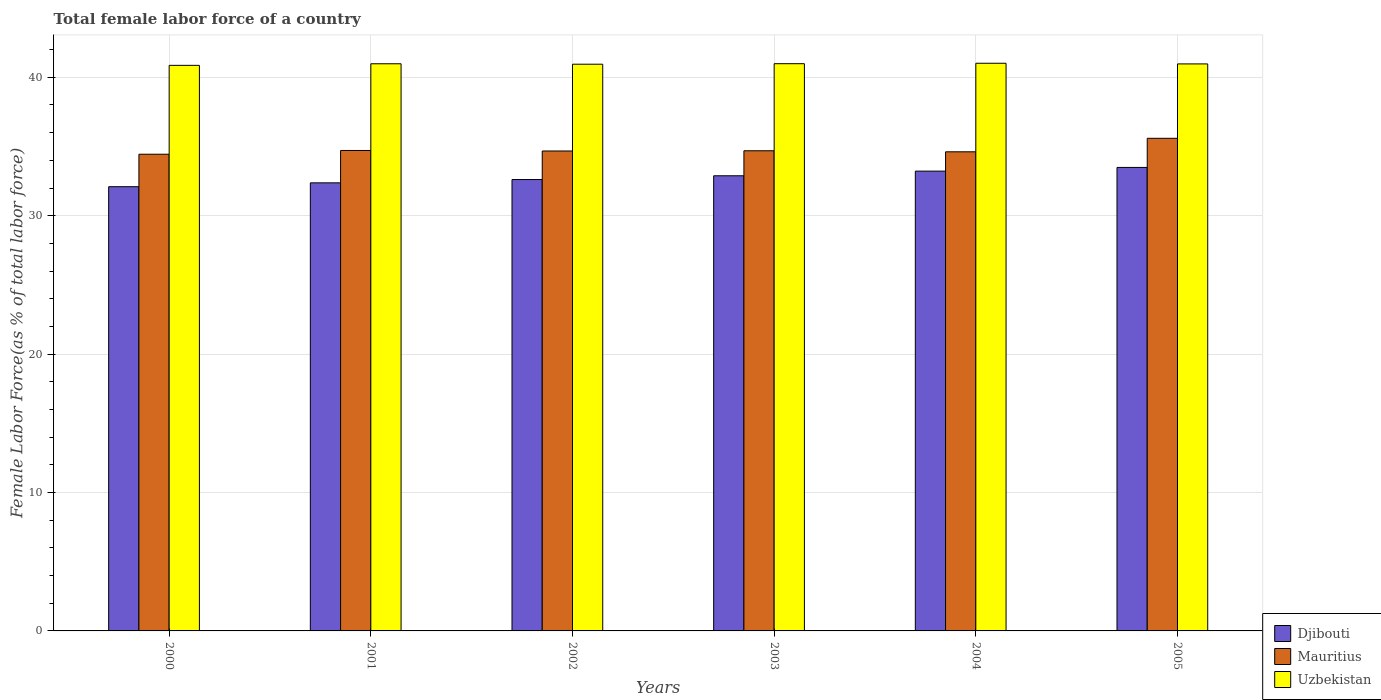What is the label of the 5th group of bars from the left?
Provide a succinct answer. 2004. In how many cases, is the number of bars for a given year not equal to the number of legend labels?
Your answer should be compact. 0. What is the percentage of female labor force in Mauritius in 2003?
Your answer should be very brief. 34.69. Across all years, what is the maximum percentage of female labor force in Mauritius?
Give a very brief answer. 35.59. Across all years, what is the minimum percentage of female labor force in Djibouti?
Ensure brevity in your answer.  32.1. In which year was the percentage of female labor force in Uzbekistan minimum?
Offer a terse response. 2000. What is the total percentage of female labor force in Uzbekistan in the graph?
Your response must be concise. 245.75. What is the difference between the percentage of female labor force in Mauritius in 2002 and that in 2004?
Offer a terse response. 0.06. What is the difference between the percentage of female labor force in Mauritius in 2001 and the percentage of female labor force in Uzbekistan in 2004?
Your answer should be very brief. -6.3. What is the average percentage of female labor force in Mauritius per year?
Give a very brief answer. 34.79. In the year 2003, what is the difference between the percentage of female labor force in Uzbekistan and percentage of female labor force in Djibouti?
Your response must be concise. 8.1. What is the ratio of the percentage of female labor force in Uzbekistan in 2004 to that in 2005?
Provide a short and direct response. 1. Is the difference between the percentage of female labor force in Uzbekistan in 2000 and 2003 greater than the difference between the percentage of female labor force in Djibouti in 2000 and 2003?
Keep it short and to the point. Yes. What is the difference between the highest and the second highest percentage of female labor force in Uzbekistan?
Give a very brief answer. 0.03. What is the difference between the highest and the lowest percentage of female labor force in Mauritius?
Your answer should be compact. 1.15. Is the sum of the percentage of female labor force in Mauritius in 2002 and 2005 greater than the maximum percentage of female labor force in Uzbekistan across all years?
Make the answer very short. Yes. What does the 1st bar from the left in 2001 represents?
Keep it short and to the point. Djibouti. What does the 3rd bar from the right in 2004 represents?
Your answer should be compact. Djibouti. Are all the bars in the graph horizontal?
Your answer should be very brief. No. What is the difference between two consecutive major ticks on the Y-axis?
Make the answer very short. 10. Does the graph contain any zero values?
Your answer should be compact. No. Where does the legend appear in the graph?
Keep it short and to the point. Bottom right. How are the legend labels stacked?
Make the answer very short. Vertical. What is the title of the graph?
Give a very brief answer. Total female labor force of a country. Does "Myanmar" appear as one of the legend labels in the graph?
Ensure brevity in your answer.  No. What is the label or title of the X-axis?
Offer a very short reply. Years. What is the label or title of the Y-axis?
Your answer should be very brief. Female Labor Force(as % of total labor force). What is the Female Labor Force(as % of total labor force) of Djibouti in 2000?
Provide a succinct answer. 32.1. What is the Female Labor Force(as % of total labor force) of Mauritius in 2000?
Provide a succinct answer. 34.44. What is the Female Labor Force(as % of total labor force) of Uzbekistan in 2000?
Provide a succinct answer. 40.86. What is the Female Labor Force(as % of total labor force) in Djibouti in 2001?
Provide a succinct answer. 32.37. What is the Female Labor Force(as % of total labor force) in Mauritius in 2001?
Offer a very short reply. 34.71. What is the Female Labor Force(as % of total labor force) in Uzbekistan in 2001?
Give a very brief answer. 40.98. What is the Female Labor Force(as % of total labor force) of Djibouti in 2002?
Provide a succinct answer. 32.61. What is the Female Labor Force(as % of total labor force) of Mauritius in 2002?
Give a very brief answer. 34.68. What is the Female Labor Force(as % of total labor force) in Uzbekistan in 2002?
Your answer should be very brief. 40.95. What is the Female Labor Force(as % of total labor force) in Djibouti in 2003?
Give a very brief answer. 32.89. What is the Female Labor Force(as % of total labor force) of Mauritius in 2003?
Give a very brief answer. 34.69. What is the Female Labor Force(as % of total labor force) in Uzbekistan in 2003?
Offer a very short reply. 40.98. What is the Female Labor Force(as % of total labor force) of Djibouti in 2004?
Your answer should be compact. 33.22. What is the Female Labor Force(as % of total labor force) in Mauritius in 2004?
Provide a short and direct response. 34.62. What is the Female Labor Force(as % of total labor force) of Uzbekistan in 2004?
Keep it short and to the point. 41.01. What is the Female Labor Force(as % of total labor force) of Djibouti in 2005?
Provide a succinct answer. 33.49. What is the Female Labor Force(as % of total labor force) of Mauritius in 2005?
Give a very brief answer. 35.59. What is the Female Labor Force(as % of total labor force) in Uzbekistan in 2005?
Offer a terse response. 40.97. Across all years, what is the maximum Female Labor Force(as % of total labor force) in Djibouti?
Provide a succinct answer. 33.49. Across all years, what is the maximum Female Labor Force(as % of total labor force) in Mauritius?
Make the answer very short. 35.59. Across all years, what is the maximum Female Labor Force(as % of total labor force) in Uzbekistan?
Keep it short and to the point. 41.01. Across all years, what is the minimum Female Labor Force(as % of total labor force) in Djibouti?
Provide a short and direct response. 32.1. Across all years, what is the minimum Female Labor Force(as % of total labor force) of Mauritius?
Give a very brief answer. 34.44. Across all years, what is the minimum Female Labor Force(as % of total labor force) of Uzbekistan?
Your answer should be very brief. 40.86. What is the total Female Labor Force(as % of total labor force) in Djibouti in the graph?
Provide a succinct answer. 196.68. What is the total Female Labor Force(as % of total labor force) in Mauritius in the graph?
Offer a very short reply. 208.73. What is the total Female Labor Force(as % of total labor force) of Uzbekistan in the graph?
Provide a short and direct response. 245.75. What is the difference between the Female Labor Force(as % of total labor force) of Djibouti in 2000 and that in 2001?
Offer a very short reply. -0.28. What is the difference between the Female Labor Force(as % of total labor force) in Mauritius in 2000 and that in 2001?
Provide a succinct answer. -0.27. What is the difference between the Female Labor Force(as % of total labor force) of Uzbekistan in 2000 and that in 2001?
Your answer should be very brief. -0.11. What is the difference between the Female Labor Force(as % of total labor force) of Djibouti in 2000 and that in 2002?
Your response must be concise. -0.52. What is the difference between the Female Labor Force(as % of total labor force) of Mauritius in 2000 and that in 2002?
Give a very brief answer. -0.23. What is the difference between the Female Labor Force(as % of total labor force) in Uzbekistan in 2000 and that in 2002?
Provide a short and direct response. -0.08. What is the difference between the Female Labor Force(as % of total labor force) in Djibouti in 2000 and that in 2003?
Offer a very short reply. -0.79. What is the difference between the Female Labor Force(as % of total labor force) of Mauritius in 2000 and that in 2003?
Ensure brevity in your answer.  -0.25. What is the difference between the Female Labor Force(as % of total labor force) of Uzbekistan in 2000 and that in 2003?
Ensure brevity in your answer.  -0.12. What is the difference between the Female Labor Force(as % of total labor force) of Djibouti in 2000 and that in 2004?
Offer a terse response. -1.13. What is the difference between the Female Labor Force(as % of total labor force) in Mauritius in 2000 and that in 2004?
Make the answer very short. -0.17. What is the difference between the Female Labor Force(as % of total labor force) of Uzbekistan in 2000 and that in 2004?
Ensure brevity in your answer.  -0.15. What is the difference between the Female Labor Force(as % of total labor force) of Djibouti in 2000 and that in 2005?
Keep it short and to the point. -1.39. What is the difference between the Female Labor Force(as % of total labor force) of Mauritius in 2000 and that in 2005?
Ensure brevity in your answer.  -1.15. What is the difference between the Female Labor Force(as % of total labor force) of Uzbekistan in 2000 and that in 2005?
Provide a succinct answer. -0.1. What is the difference between the Female Labor Force(as % of total labor force) of Djibouti in 2001 and that in 2002?
Your answer should be very brief. -0.24. What is the difference between the Female Labor Force(as % of total labor force) in Mauritius in 2001 and that in 2002?
Keep it short and to the point. 0.04. What is the difference between the Female Labor Force(as % of total labor force) of Uzbekistan in 2001 and that in 2002?
Provide a short and direct response. 0.03. What is the difference between the Female Labor Force(as % of total labor force) of Djibouti in 2001 and that in 2003?
Your response must be concise. -0.51. What is the difference between the Female Labor Force(as % of total labor force) of Mauritius in 2001 and that in 2003?
Your answer should be very brief. 0.02. What is the difference between the Female Labor Force(as % of total labor force) in Uzbekistan in 2001 and that in 2003?
Make the answer very short. -0.01. What is the difference between the Female Labor Force(as % of total labor force) in Djibouti in 2001 and that in 2004?
Offer a terse response. -0.85. What is the difference between the Female Labor Force(as % of total labor force) of Mauritius in 2001 and that in 2004?
Offer a very short reply. 0.1. What is the difference between the Female Labor Force(as % of total labor force) of Uzbekistan in 2001 and that in 2004?
Ensure brevity in your answer.  -0.04. What is the difference between the Female Labor Force(as % of total labor force) in Djibouti in 2001 and that in 2005?
Offer a terse response. -1.11. What is the difference between the Female Labor Force(as % of total labor force) in Mauritius in 2001 and that in 2005?
Offer a terse response. -0.88. What is the difference between the Female Labor Force(as % of total labor force) in Uzbekistan in 2001 and that in 2005?
Ensure brevity in your answer.  0.01. What is the difference between the Female Labor Force(as % of total labor force) of Djibouti in 2002 and that in 2003?
Your answer should be compact. -0.27. What is the difference between the Female Labor Force(as % of total labor force) of Mauritius in 2002 and that in 2003?
Offer a terse response. -0.02. What is the difference between the Female Labor Force(as % of total labor force) in Uzbekistan in 2002 and that in 2003?
Your answer should be compact. -0.04. What is the difference between the Female Labor Force(as % of total labor force) in Djibouti in 2002 and that in 2004?
Ensure brevity in your answer.  -0.61. What is the difference between the Female Labor Force(as % of total labor force) of Mauritius in 2002 and that in 2004?
Provide a succinct answer. 0.06. What is the difference between the Female Labor Force(as % of total labor force) in Uzbekistan in 2002 and that in 2004?
Give a very brief answer. -0.07. What is the difference between the Female Labor Force(as % of total labor force) of Djibouti in 2002 and that in 2005?
Keep it short and to the point. -0.87. What is the difference between the Female Labor Force(as % of total labor force) of Mauritius in 2002 and that in 2005?
Keep it short and to the point. -0.92. What is the difference between the Female Labor Force(as % of total labor force) of Uzbekistan in 2002 and that in 2005?
Keep it short and to the point. -0.02. What is the difference between the Female Labor Force(as % of total labor force) in Djibouti in 2003 and that in 2004?
Provide a succinct answer. -0.34. What is the difference between the Female Labor Force(as % of total labor force) of Mauritius in 2003 and that in 2004?
Ensure brevity in your answer.  0.08. What is the difference between the Female Labor Force(as % of total labor force) in Uzbekistan in 2003 and that in 2004?
Give a very brief answer. -0.03. What is the difference between the Female Labor Force(as % of total labor force) of Djibouti in 2003 and that in 2005?
Your answer should be compact. -0.6. What is the difference between the Female Labor Force(as % of total labor force) in Mauritius in 2003 and that in 2005?
Keep it short and to the point. -0.9. What is the difference between the Female Labor Force(as % of total labor force) in Uzbekistan in 2003 and that in 2005?
Offer a terse response. 0.02. What is the difference between the Female Labor Force(as % of total labor force) in Djibouti in 2004 and that in 2005?
Your response must be concise. -0.27. What is the difference between the Female Labor Force(as % of total labor force) in Mauritius in 2004 and that in 2005?
Make the answer very short. -0.98. What is the difference between the Female Labor Force(as % of total labor force) in Uzbekistan in 2004 and that in 2005?
Your response must be concise. 0.05. What is the difference between the Female Labor Force(as % of total labor force) in Djibouti in 2000 and the Female Labor Force(as % of total labor force) in Mauritius in 2001?
Your answer should be compact. -2.62. What is the difference between the Female Labor Force(as % of total labor force) in Djibouti in 2000 and the Female Labor Force(as % of total labor force) in Uzbekistan in 2001?
Offer a very short reply. -8.88. What is the difference between the Female Labor Force(as % of total labor force) in Mauritius in 2000 and the Female Labor Force(as % of total labor force) in Uzbekistan in 2001?
Make the answer very short. -6.54. What is the difference between the Female Labor Force(as % of total labor force) of Djibouti in 2000 and the Female Labor Force(as % of total labor force) of Mauritius in 2002?
Give a very brief answer. -2.58. What is the difference between the Female Labor Force(as % of total labor force) in Djibouti in 2000 and the Female Labor Force(as % of total labor force) in Uzbekistan in 2002?
Offer a very short reply. -8.85. What is the difference between the Female Labor Force(as % of total labor force) in Mauritius in 2000 and the Female Labor Force(as % of total labor force) in Uzbekistan in 2002?
Offer a terse response. -6.5. What is the difference between the Female Labor Force(as % of total labor force) in Djibouti in 2000 and the Female Labor Force(as % of total labor force) in Mauritius in 2003?
Keep it short and to the point. -2.6. What is the difference between the Female Labor Force(as % of total labor force) in Djibouti in 2000 and the Female Labor Force(as % of total labor force) in Uzbekistan in 2003?
Ensure brevity in your answer.  -8.89. What is the difference between the Female Labor Force(as % of total labor force) in Mauritius in 2000 and the Female Labor Force(as % of total labor force) in Uzbekistan in 2003?
Give a very brief answer. -6.54. What is the difference between the Female Labor Force(as % of total labor force) of Djibouti in 2000 and the Female Labor Force(as % of total labor force) of Mauritius in 2004?
Ensure brevity in your answer.  -2.52. What is the difference between the Female Labor Force(as % of total labor force) in Djibouti in 2000 and the Female Labor Force(as % of total labor force) in Uzbekistan in 2004?
Make the answer very short. -8.92. What is the difference between the Female Labor Force(as % of total labor force) of Mauritius in 2000 and the Female Labor Force(as % of total labor force) of Uzbekistan in 2004?
Provide a succinct answer. -6.57. What is the difference between the Female Labor Force(as % of total labor force) in Djibouti in 2000 and the Female Labor Force(as % of total labor force) in Mauritius in 2005?
Provide a succinct answer. -3.5. What is the difference between the Female Labor Force(as % of total labor force) of Djibouti in 2000 and the Female Labor Force(as % of total labor force) of Uzbekistan in 2005?
Make the answer very short. -8.87. What is the difference between the Female Labor Force(as % of total labor force) of Mauritius in 2000 and the Female Labor Force(as % of total labor force) of Uzbekistan in 2005?
Provide a succinct answer. -6.52. What is the difference between the Female Labor Force(as % of total labor force) of Djibouti in 2001 and the Female Labor Force(as % of total labor force) of Mauritius in 2002?
Keep it short and to the point. -2.3. What is the difference between the Female Labor Force(as % of total labor force) in Djibouti in 2001 and the Female Labor Force(as % of total labor force) in Uzbekistan in 2002?
Your response must be concise. -8.57. What is the difference between the Female Labor Force(as % of total labor force) of Mauritius in 2001 and the Female Labor Force(as % of total labor force) of Uzbekistan in 2002?
Provide a succinct answer. -6.23. What is the difference between the Female Labor Force(as % of total labor force) in Djibouti in 2001 and the Female Labor Force(as % of total labor force) in Mauritius in 2003?
Provide a short and direct response. -2.32. What is the difference between the Female Labor Force(as % of total labor force) in Djibouti in 2001 and the Female Labor Force(as % of total labor force) in Uzbekistan in 2003?
Provide a succinct answer. -8.61. What is the difference between the Female Labor Force(as % of total labor force) of Mauritius in 2001 and the Female Labor Force(as % of total labor force) of Uzbekistan in 2003?
Your response must be concise. -6.27. What is the difference between the Female Labor Force(as % of total labor force) of Djibouti in 2001 and the Female Labor Force(as % of total labor force) of Mauritius in 2004?
Ensure brevity in your answer.  -2.24. What is the difference between the Female Labor Force(as % of total labor force) of Djibouti in 2001 and the Female Labor Force(as % of total labor force) of Uzbekistan in 2004?
Offer a very short reply. -8.64. What is the difference between the Female Labor Force(as % of total labor force) of Mauritius in 2001 and the Female Labor Force(as % of total labor force) of Uzbekistan in 2004?
Make the answer very short. -6.3. What is the difference between the Female Labor Force(as % of total labor force) of Djibouti in 2001 and the Female Labor Force(as % of total labor force) of Mauritius in 2005?
Keep it short and to the point. -3.22. What is the difference between the Female Labor Force(as % of total labor force) in Djibouti in 2001 and the Female Labor Force(as % of total labor force) in Uzbekistan in 2005?
Offer a very short reply. -8.59. What is the difference between the Female Labor Force(as % of total labor force) of Mauritius in 2001 and the Female Labor Force(as % of total labor force) of Uzbekistan in 2005?
Make the answer very short. -6.25. What is the difference between the Female Labor Force(as % of total labor force) of Djibouti in 2002 and the Female Labor Force(as % of total labor force) of Mauritius in 2003?
Your answer should be compact. -2.08. What is the difference between the Female Labor Force(as % of total labor force) of Djibouti in 2002 and the Female Labor Force(as % of total labor force) of Uzbekistan in 2003?
Offer a terse response. -8.37. What is the difference between the Female Labor Force(as % of total labor force) of Mauritius in 2002 and the Female Labor Force(as % of total labor force) of Uzbekistan in 2003?
Provide a succinct answer. -6.31. What is the difference between the Female Labor Force(as % of total labor force) in Djibouti in 2002 and the Female Labor Force(as % of total labor force) in Mauritius in 2004?
Keep it short and to the point. -2. What is the difference between the Female Labor Force(as % of total labor force) in Djibouti in 2002 and the Female Labor Force(as % of total labor force) in Uzbekistan in 2004?
Provide a short and direct response. -8.4. What is the difference between the Female Labor Force(as % of total labor force) in Mauritius in 2002 and the Female Labor Force(as % of total labor force) in Uzbekistan in 2004?
Give a very brief answer. -6.34. What is the difference between the Female Labor Force(as % of total labor force) in Djibouti in 2002 and the Female Labor Force(as % of total labor force) in Mauritius in 2005?
Your answer should be compact. -2.98. What is the difference between the Female Labor Force(as % of total labor force) of Djibouti in 2002 and the Female Labor Force(as % of total labor force) of Uzbekistan in 2005?
Make the answer very short. -8.35. What is the difference between the Female Labor Force(as % of total labor force) in Mauritius in 2002 and the Female Labor Force(as % of total labor force) in Uzbekistan in 2005?
Provide a short and direct response. -6.29. What is the difference between the Female Labor Force(as % of total labor force) of Djibouti in 2003 and the Female Labor Force(as % of total labor force) of Mauritius in 2004?
Offer a terse response. -1.73. What is the difference between the Female Labor Force(as % of total labor force) in Djibouti in 2003 and the Female Labor Force(as % of total labor force) in Uzbekistan in 2004?
Provide a short and direct response. -8.13. What is the difference between the Female Labor Force(as % of total labor force) in Mauritius in 2003 and the Female Labor Force(as % of total labor force) in Uzbekistan in 2004?
Offer a very short reply. -6.32. What is the difference between the Female Labor Force(as % of total labor force) in Djibouti in 2003 and the Female Labor Force(as % of total labor force) in Mauritius in 2005?
Offer a very short reply. -2.71. What is the difference between the Female Labor Force(as % of total labor force) in Djibouti in 2003 and the Female Labor Force(as % of total labor force) in Uzbekistan in 2005?
Your answer should be very brief. -8.08. What is the difference between the Female Labor Force(as % of total labor force) in Mauritius in 2003 and the Female Labor Force(as % of total labor force) in Uzbekistan in 2005?
Provide a succinct answer. -6.27. What is the difference between the Female Labor Force(as % of total labor force) in Djibouti in 2004 and the Female Labor Force(as % of total labor force) in Mauritius in 2005?
Provide a short and direct response. -2.37. What is the difference between the Female Labor Force(as % of total labor force) of Djibouti in 2004 and the Female Labor Force(as % of total labor force) of Uzbekistan in 2005?
Keep it short and to the point. -7.75. What is the difference between the Female Labor Force(as % of total labor force) in Mauritius in 2004 and the Female Labor Force(as % of total labor force) in Uzbekistan in 2005?
Give a very brief answer. -6.35. What is the average Female Labor Force(as % of total labor force) of Djibouti per year?
Provide a succinct answer. 32.78. What is the average Female Labor Force(as % of total labor force) of Mauritius per year?
Give a very brief answer. 34.79. What is the average Female Labor Force(as % of total labor force) of Uzbekistan per year?
Your response must be concise. 40.96. In the year 2000, what is the difference between the Female Labor Force(as % of total labor force) of Djibouti and Female Labor Force(as % of total labor force) of Mauritius?
Your answer should be compact. -2.35. In the year 2000, what is the difference between the Female Labor Force(as % of total labor force) of Djibouti and Female Labor Force(as % of total labor force) of Uzbekistan?
Offer a very short reply. -8.77. In the year 2000, what is the difference between the Female Labor Force(as % of total labor force) in Mauritius and Female Labor Force(as % of total labor force) in Uzbekistan?
Give a very brief answer. -6.42. In the year 2001, what is the difference between the Female Labor Force(as % of total labor force) of Djibouti and Female Labor Force(as % of total labor force) of Mauritius?
Your answer should be compact. -2.34. In the year 2001, what is the difference between the Female Labor Force(as % of total labor force) of Djibouti and Female Labor Force(as % of total labor force) of Uzbekistan?
Keep it short and to the point. -8.6. In the year 2001, what is the difference between the Female Labor Force(as % of total labor force) in Mauritius and Female Labor Force(as % of total labor force) in Uzbekistan?
Offer a very short reply. -6.26. In the year 2002, what is the difference between the Female Labor Force(as % of total labor force) of Djibouti and Female Labor Force(as % of total labor force) of Mauritius?
Keep it short and to the point. -2.06. In the year 2002, what is the difference between the Female Labor Force(as % of total labor force) in Djibouti and Female Labor Force(as % of total labor force) in Uzbekistan?
Keep it short and to the point. -8.33. In the year 2002, what is the difference between the Female Labor Force(as % of total labor force) in Mauritius and Female Labor Force(as % of total labor force) in Uzbekistan?
Your answer should be very brief. -6.27. In the year 2003, what is the difference between the Female Labor Force(as % of total labor force) in Djibouti and Female Labor Force(as % of total labor force) in Mauritius?
Offer a terse response. -1.81. In the year 2003, what is the difference between the Female Labor Force(as % of total labor force) of Djibouti and Female Labor Force(as % of total labor force) of Uzbekistan?
Ensure brevity in your answer.  -8.1. In the year 2003, what is the difference between the Female Labor Force(as % of total labor force) of Mauritius and Female Labor Force(as % of total labor force) of Uzbekistan?
Give a very brief answer. -6.29. In the year 2004, what is the difference between the Female Labor Force(as % of total labor force) in Djibouti and Female Labor Force(as % of total labor force) in Mauritius?
Your answer should be compact. -1.4. In the year 2004, what is the difference between the Female Labor Force(as % of total labor force) in Djibouti and Female Labor Force(as % of total labor force) in Uzbekistan?
Your answer should be very brief. -7.79. In the year 2004, what is the difference between the Female Labor Force(as % of total labor force) in Mauritius and Female Labor Force(as % of total labor force) in Uzbekistan?
Keep it short and to the point. -6.4. In the year 2005, what is the difference between the Female Labor Force(as % of total labor force) in Djibouti and Female Labor Force(as % of total labor force) in Mauritius?
Your answer should be compact. -2.1. In the year 2005, what is the difference between the Female Labor Force(as % of total labor force) of Djibouti and Female Labor Force(as % of total labor force) of Uzbekistan?
Make the answer very short. -7.48. In the year 2005, what is the difference between the Female Labor Force(as % of total labor force) of Mauritius and Female Labor Force(as % of total labor force) of Uzbekistan?
Give a very brief answer. -5.37. What is the ratio of the Female Labor Force(as % of total labor force) in Djibouti in 2000 to that in 2001?
Your answer should be very brief. 0.99. What is the ratio of the Female Labor Force(as % of total labor force) in Uzbekistan in 2000 to that in 2001?
Ensure brevity in your answer.  1. What is the ratio of the Female Labor Force(as % of total labor force) in Djibouti in 2000 to that in 2002?
Your response must be concise. 0.98. What is the ratio of the Female Labor Force(as % of total labor force) in Mauritius in 2000 to that in 2002?
Offer a very short reply. 0.99. What is the ratio of the Female Labor Force(as % of total labor force) in Uzbekistan in 2000 to that in 2003?
Provide a short and direct response. 1. What is the ratio of the Female Labor Force(as % of total labor force) in Djibouti in 2000 to that in 2004?
Your response must be concise. 0.97. What is the ratio of the Female Labor Force(as % of total labor force) of Mauritius in 2000 to that in 2004?
Provide a short and direct response. 0.99. What is the ratio of the Female Labor Force(as % of total labor force) in Djibouti in 2000 to that in 2005?
Your answer should be compact. 0.96. What is the ratio of the Female Labor Force(as % of total labor force) of Mauritius in 2000 to that in 2005?
Offer a very short reply. 0.97. What is the ratio of the Female Labor Force(as % of total labor force) in Mauritius in 2001 to that in 2002?
Keep it short and to the point. 1. What is the ratio of the Female Labor Force(as % of total labor force) of Uzbekistan in 2001 to that in 2002?
Keep it short and to the point. 1. What is the ratio of the Female Labor Force(as % of total labor force) in Djibouti in 2001 to that in 2003?
Provide a succinct answer. 0.98. What is the ratio of the Female Labor Force(as % of total labor force) of Mauritius in 2001 to that in 2003?
Offer a very short reply. 1. What is the ratio of the Female Labor Force(as % of total labor force) of Djibouti in 2001 to that in 2004?
Keep it short and to the point. 0.97. What is the ratio of the Female Labor Force(as % of total labor force) in Uzbekistan in 2001 to that in 2004?
Offer a very short reply. 1. What is the ratio of the Female Labor Force(as % of total labor force) in Djibouti in 2001 to that in 2005?
Your answer should be compact. 0.97. What is the ratio of the Female Labor Force(as % of total labor force) of Mauritius in 2001 to that in 2005?
Give a very brief answer. 0.98. What is the ratio of the Female Labor Force(as % of total labor force) in Uzbekistan in 2001 to that in 2005?
Give a very brief answer. 1. What is the ratio of the Female Labor Force(as % of total labor force) in Uzbekistan in 2002 to that in 2003?
Your answer should be compact. 1. What is the ratio of the Female Labor Force(as % of total labor force) of Djibouti in 2002 to that in 2004?
Give a very brief answer. 0.98. What is the ratio of the Female Labor Force(as % of total labor force) of Mauritius in 2002 to that in 2004?
Make the answer very short. 1. What is the ratio of the Female Labor Force(as % of total labor force) of Uzbekistan in 2002 to that in 2004?
Make the answer very short. 1. What is the ratio of the Female Labor Force(as % of total labor force) of Djibouti in 2002 to that in 2005?
Give a very brief answer. 0.97. What is the ratio of the Female Labor Force(as % of total labor force) of Mauritius in 2002 to that in 2005?
Provide a short and direct response. 0.97. What is the ratio of the Female Labor Force(as % of total labor force) of Uzbekistan in 2002 to that in 2005?
Offer a very short reply. 1. What is the ratio of the Female Labor Force(as % of total labor force) in Mauritius in 2003 to that in 2004?
Provide a short and direct response. 1. What is the ratio of the Female Labor Force(as % of total labor force) of Djibouti in 2003 to that in 2005?
Provide a succinct answer. 0.98. What is the ratio of the Female Labor Force(as % of total labor force) of Mauritius in 2003 to that in 2005?
Give a very brief answer. 0.97. What is the ratio of the Female Labor Force(as % of total labor force) of Uzbekistan in 2003 to that in 2005?
Make the answer very short. 1. What is the ratio of the Female Labor Force(as % of total labor force) in Djibouti in 2004 to that in 2005?
Offer a very short reply. 0.99. What is the ratio of the Female Labor Force(as % of total labor force) in Mauritius in 2004 to that in 2005?
Offer a very short reply. 0.97. What is the ratio of the Female Labor Force(as % of total labor force) in Uzbekistan in 2004 to that in 2005?
Your answer should be compact. 1. What is the difference between the highest and the second highest Female Labor Force(as % of total labor force) in Djibouti?
Your answer should be compact. 0.27. What is the difference between the highest and the second highest Female Labor Force(as % of total labor force) of Mauritius?
Make the answer very short. 0.88. What is the difference between the highest and the second highest Female Labor Force(as % of total labor force) of Uzbekistan?
Offer a very short reply. 0.03. What is the difference between the highest and the lowest Female Labor Force(as % of total labor force) in Djibouti?
Your answer should be very brief. 1.39. What is the difference between the highest and the lowest Female Labor Force(as % of total labor force) of Mauritius?
Offer a very short reply. 1.15. What is the difference between the highest and the lowest Female Labor Force(as % of total labor force) in Uzbekistan?
Ensure brevity in your answer.  0.15. 